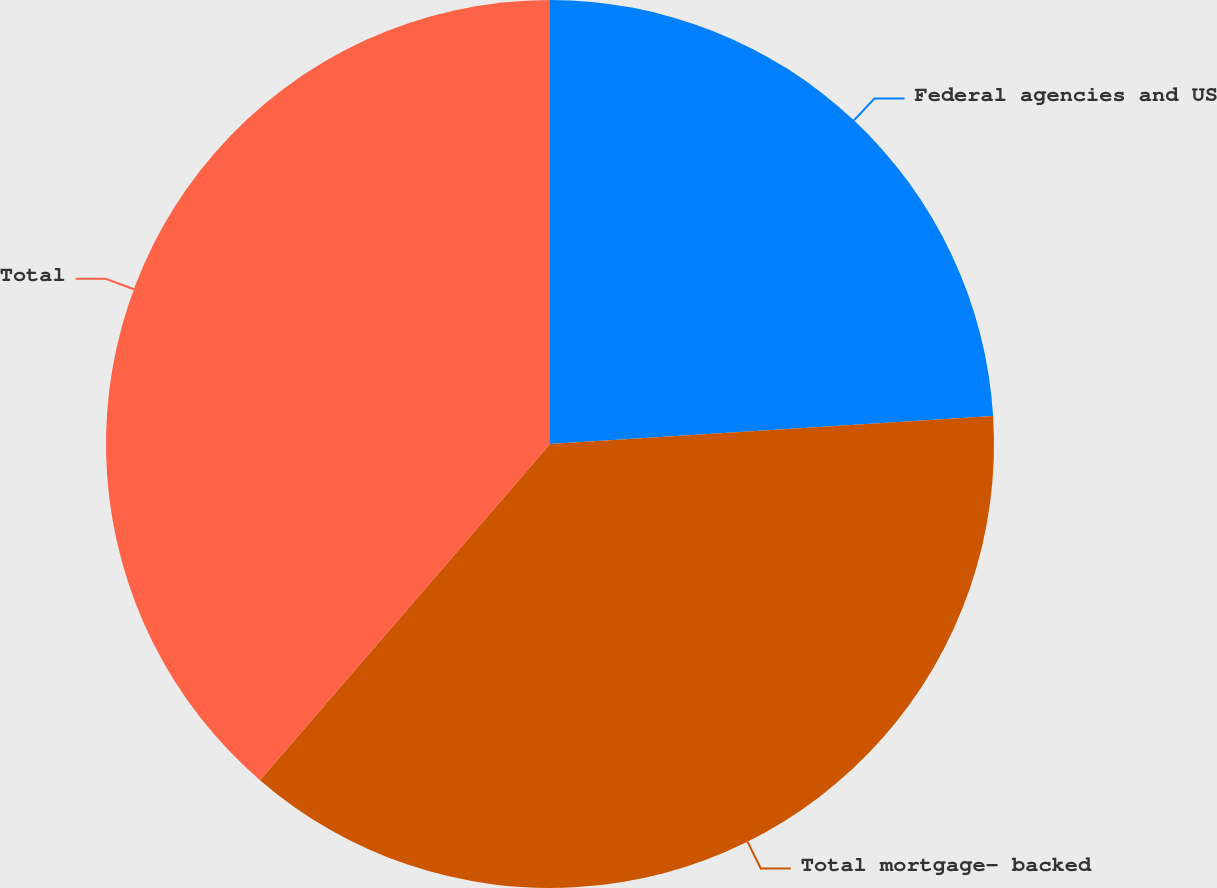Convert chart to OTSL. <chart><loc_0><loc_0><loc_500><loc_500><pie_chart><fcel>Federal agencies and US<fcel>Total mortgage- backed<fcel>Total<nl><fcel>24.0%<fcel>37.33%<fcel>38.67%<nl></chart> 